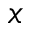<formula> <loc_0><loc_0><loc_500><loc_500>x</formula> 